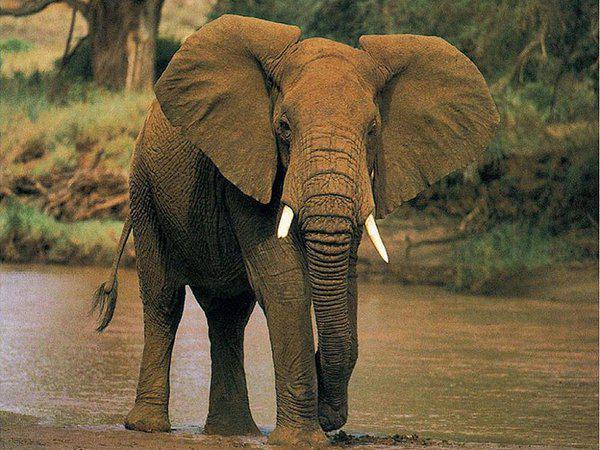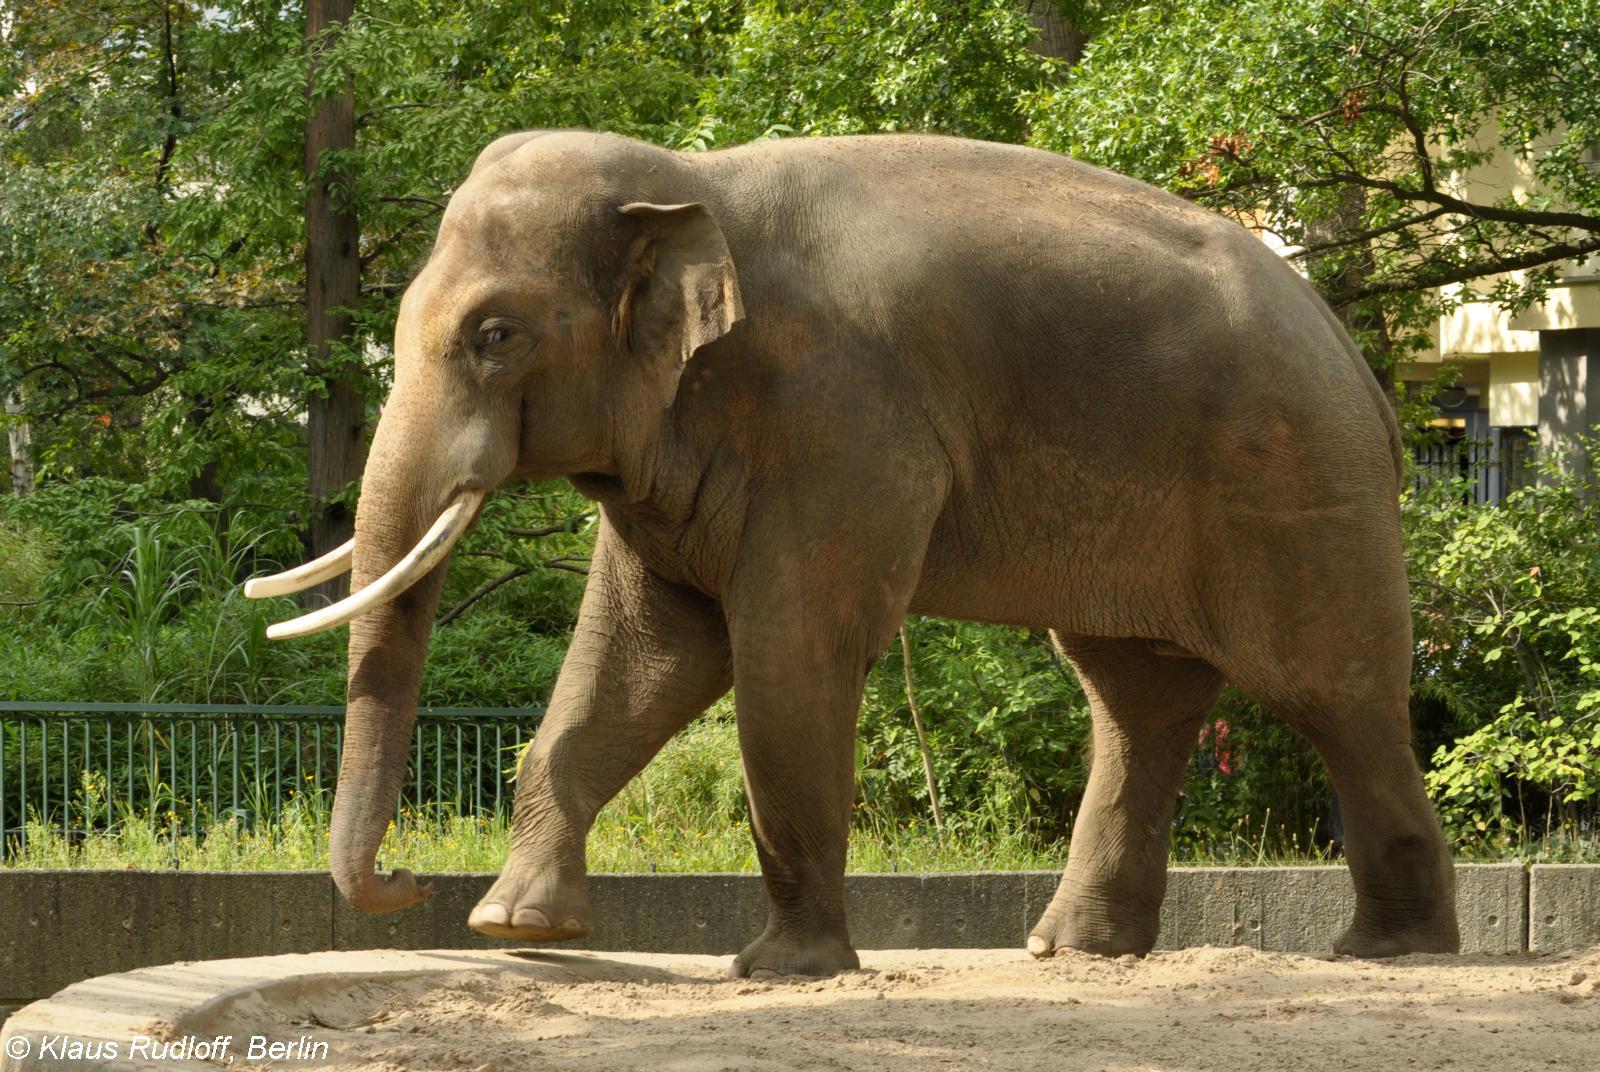The first image is the image on the left, the second image is the image on the right. Assess this claim about the two images: "A tusked elephant stands on a concrete area in the image on the right.". Correct or not? Answer yes or no. Yes. 